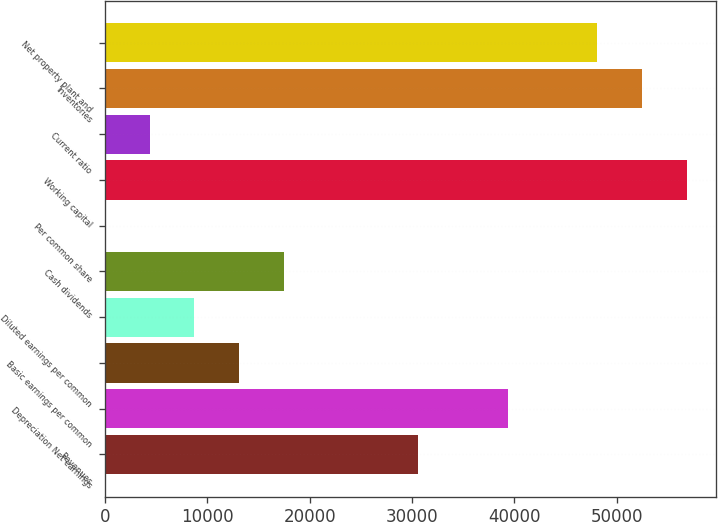Convert chart to OTSL. <chart><loc_0><loc_0><loc_500><loc_500><bar_chart><fcel>Revenues<fcel>Depreciation Net earnings<fcel>Basic earnings per common<fcel>Diluted earnings per common<fcel>Cash dividends<fcel>Per common share<fcel>Working capital<fcel>Current ratio<fcel>Inventories<fcel>Net property plant and<nl><fcel>30604.2<fcel>39348<fcel>13116.5<fcel>8744.6<fcel>17488.4<fcel>0.76<fcel>56835.7<fcel>4372.68<fcel>52463.8<fcel>48091.9<nl></chart> 